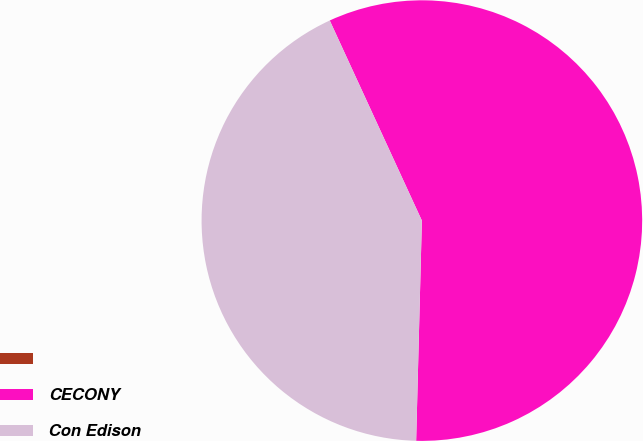<chart> <loc_0><loc_0><loc_500><loc_500><pie_chart><ecel><fcel>CECONY<fcel>Con Edison<nl><fcel>0.0%<fcel>57.28%<fcel>42.72%<nl></chart> 